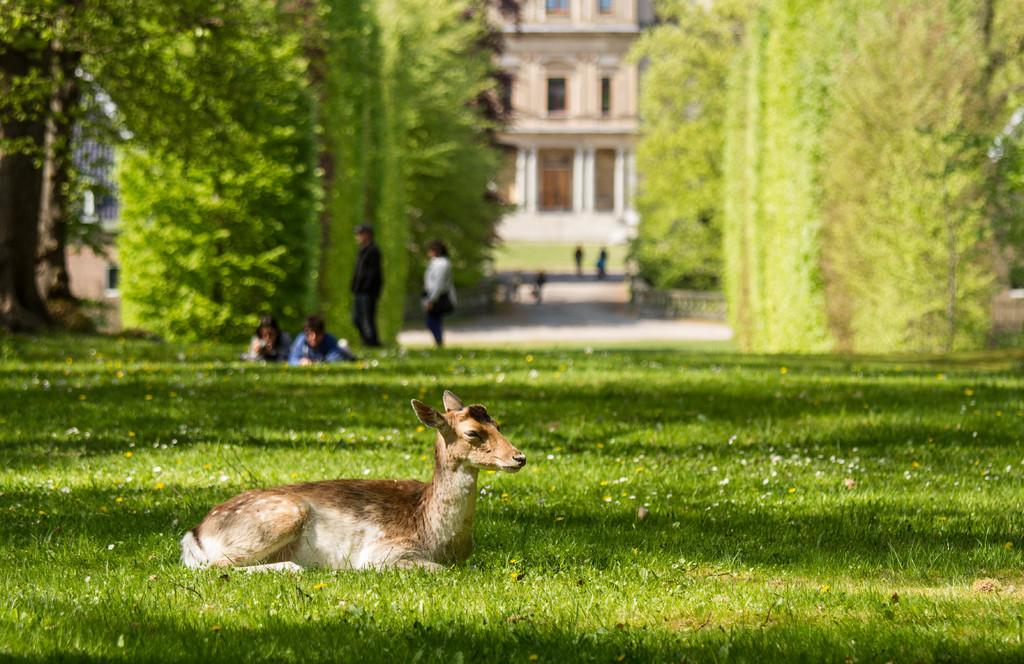What animal can be seen in the image? There is a deer laying on a grassland in the image. What else is visible in the background of the image? There are people, trees, and a building in the background of the image. How is the background of the image depicted? The background is blurred. What type of lumber is being used to build the vacation home in the image? There is no vacation home or lumber present in the image. How many birds are in the flock that is flying over the deer in the image? There is no flock of birds visible in the image; it only features a deer laying on a grassland. 